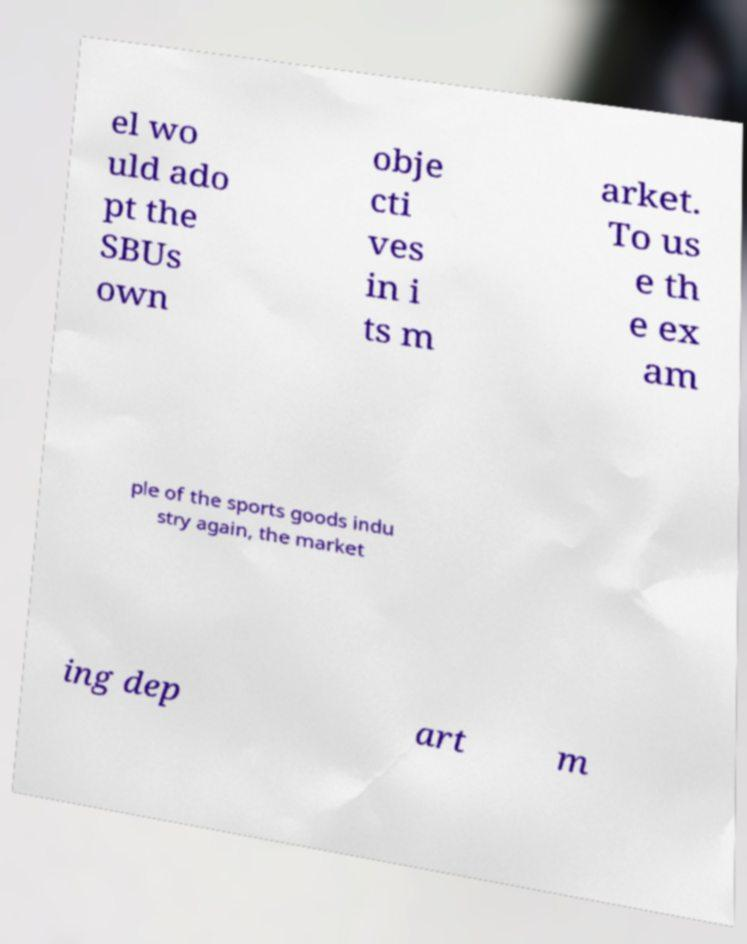Please identify and transcribe the text found in this image. el wo uld ado pt the SBUs own obje cti ves in i ts m arket. To us e th e ex am ple of the sports goods indu stry again, the market ing dep art m 